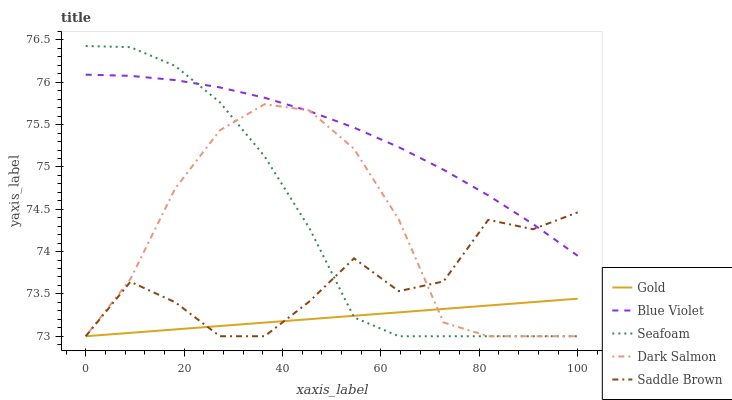Does Dark Salmon have the minimum area under the curve?
Answer yes or no. No. Does Dark Salmon have the maximum area under the curve?
Answer yes or no. No. Is Dark Salmon the smoothest?
Answer yes or no. No. Is Dark Salmon the roughest?
Answer yes or no. No. Does Blue Violet have the lowest value?
Answer yes or no. No. Does Dark Salmon have the highest value?
Answer yes or no. No. Is Gold less than Blue Violet?
Answer yes or no. Yes. Is Blue Violet greater than Gold?
Answer yes or no. Yes. Does Gold intersect Blue Violet?
Answer yes or no. No. 